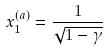Convert formula to latex. <formula><loc_0><loc_0><loc_500><loc_500>x _ { 1 } ^ { ( a ) } = \frac { 1 } { \sqrt { 1 - \gamma } }</formula> 